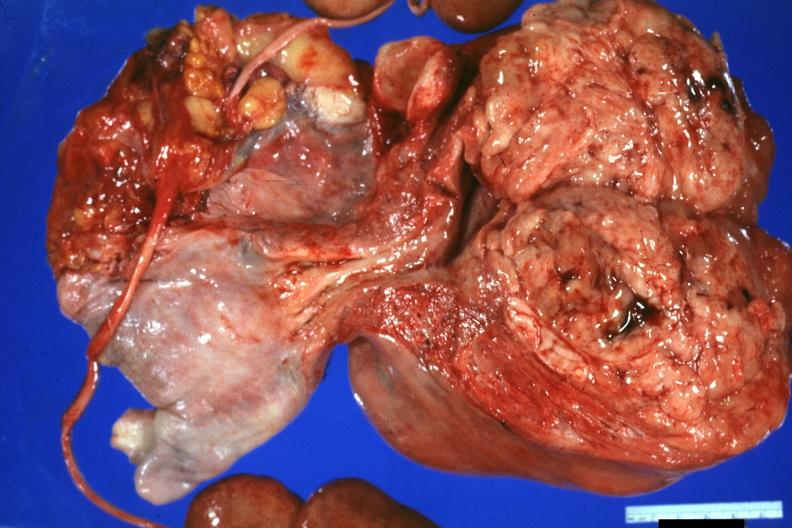what is present?
Answer the question using a single word or phrase. Uterus 